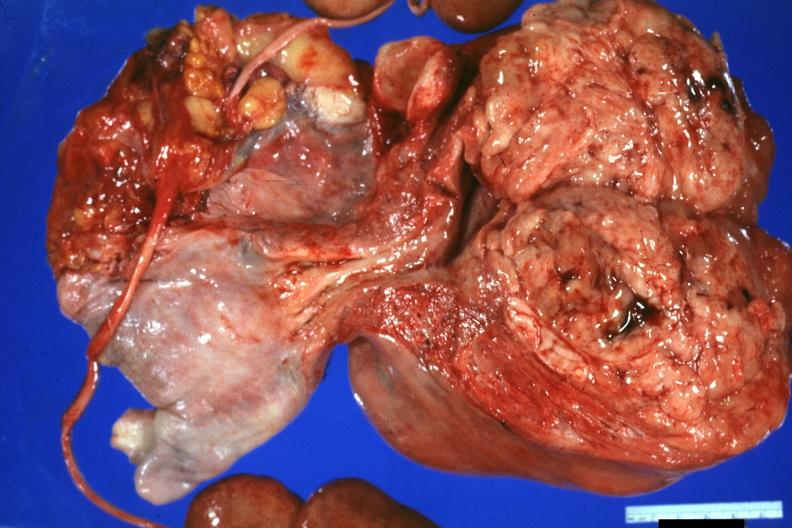what is present?
Answer the question using a single word or phrase. Uterus 